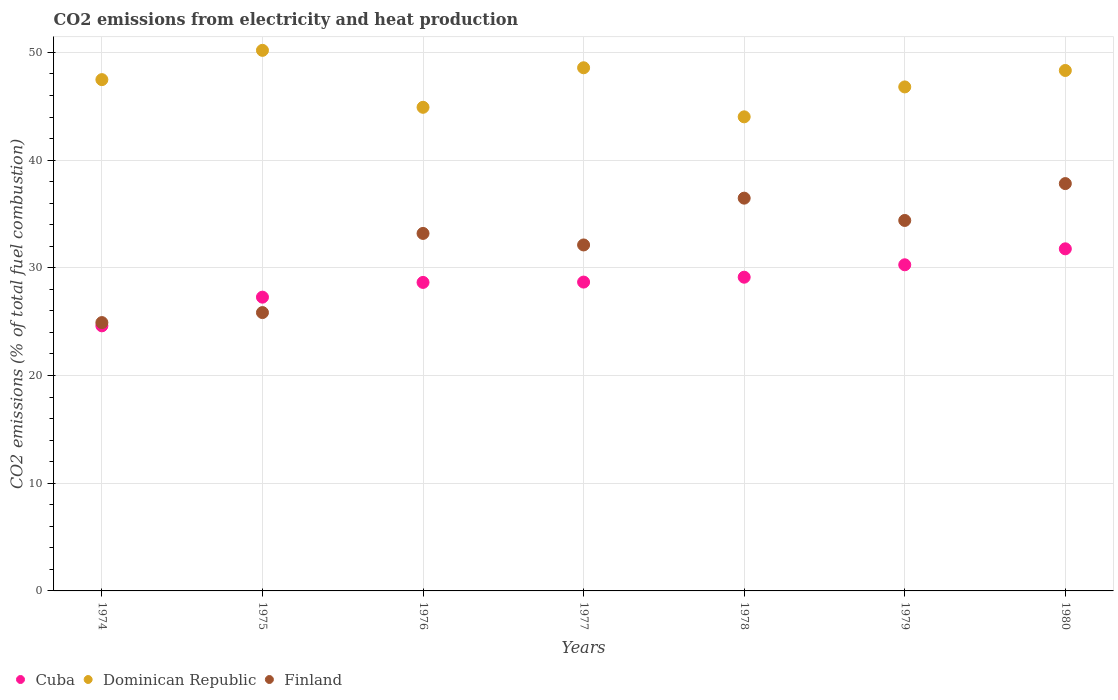How many different coloured dotlines are there?
Make the answer very short. 3. Is the number of dotlines equal to the number of legend labels?
Keep it short and to the point. Yes. What is the amount of CO2 emitted in Cuba in 1978?
Keep it short and to the point. 29.13. Across all years, what is the maximum amount of CO2 emitted in Cuba?
Keep it short and to the point. 31.77. Across all years, what is the minimum amount of CO2 emitted in Finland?
Make the answer very short. 24.92. In which year was the amount of CO2 emitted in Finland maximum?
Your answer should be very brief. 1980. In which year was the amount of CO2 emitted in Cuba minimum?
Offer a terse response. 1974. What is the total amount of CO2 emitted in Finland in the graph?
Offer a very short reply. 224.77. What is the difference between the amount of CO2 emitted in Dominican Republic in 1978 and that in 1980?
Provide a short and direct response. -4.3. What is the difference between the amount of CO2 emitted in Dominican Republic in 1977 and the amount of CO2 emitted in Finland in 1974?
Keep it short and to the point. 23.66. What is the average amount of CO2 emitted in Dominican Republic per year?
Give a very brief answer. 47.18. In the year 1980, what is the difference between the amount of CO2 emitted in Cuba and amount of CO2 emitted in Dominican Republic?
Your answer should be very brief. -16.56. What is the ratio of the amount of CO2 emitted in Finland in 1975 to that in 1977?
Your answer should be very brief. 0.8. Is the amount of CO2 emitted in Finland in 1974 less than that in 1980?
Provide a succinct answer. Yes. What is the difference between the highest and the second highest amount of CO2 emitted in Cuba?
Make the answer very short. 1.48. What is the difference between the highest and the lowest amount of CO2 emitted in Finland?
Your answer should be very brief. 12.91. Is it the case that in every year, the sum of the amount of CO2 emitted in Finland and amount of CO2 emitted in Dominican Republic  is greater than the amount of CO2 emitted in Cuba?
Your answer should be compact. Yes. Is the amount of CO2 emitted in Dominican Republic strictly greater than the amount of CO2 emitted in Finland over the years?
Make the answer very short. Yes. How many years are there in the graph?
Provide a succinct answer. 7. What is the difference between two consecutive major ticks on the Y-axis?
Keep it short and to the point. 10. Are the values on the major ticks of Y-axis written in scientific E-notation?
Your answer should be compact. No. Does the graph contain any zero values?
Make the answer very short. No. Where does the legend appear in the graph?
Your answer should be very brief. Bottom left. How are the legend labels stacked?
Provide a short and direct response. Horizontal. What is the title of the graph?
Your response must be concise. CO2 emissions from electricity and heat production. What is the label or title of the Y-axis?
Your answer should be compact. CO2 emissions (% of total fuel combustion). What is the CO2 emissions (% of total fuel combustion) of Cuba in 1974?
Your response must be concise. 24.61. What is the CO2 emissions (% of total fuel combustion) of Dominican Republic in 1974?
Your answer should be compact. 47.47. What is the CO2 emissions (% of total fuel combustion) of Finland in 1974?
Give a very brief answer. 24.92. What is the CO2 emissions (% of total fuel combustion) in Cuba in 1975?
Provide a succinct answer. 27.28. What is the CO2 emissions (% of total fuel combustion) of Dominican Republic in 1975?
Your answer should be very brief. 50.19. What is the CO2 emissions (% of total fuel combustion) in Finland in 1975?
Ensure brevity in your answer.  25.84. What is the CO2 emissions (% of total fuel combustion) in Cuba in 1976?
Your response must be concise. 28.65. What is the CO2 emissions (% of total fuel combustion) in Dominican Republic in 1976?
Your answer should be very brief. 44.91. What is the CO2 emissions (% of total fuel combustion) in Finland in 1976?
Make the answer very short. 33.19. What is the CO2 emissions (% of total fuel combustion) of Cuba in 1977?
Ensure brevity in your answer.  28.68. What is the CO2 emissions (% of total fuel combustion) in Dominican Republic in 1977?
Give a very brief answer. 48.58. What is the CO2 emissions (% of total fuel combustion) in Finland in 1977?
Provide a succinct answer. 32.12. What is the CO2 emissions (% of total fuel combustion) of Cuba in 1978?
Make the answer very short. 29.13. What is the CO2 emissions (% of total fuel combustion) in Dominican Republic in 1978?
Offer a very short reply. 44.02. What is the CO2 emissions (% of total fuel combustion) in Finland in 1978?
Provide a succinct answer. 36.47. What is the CO2 emissions (% of total fuel combustion) of Cuba in 1979?
Ensure brevity in your answer.  30.28. What is the CO2 emissions (% of total fuel combustion) in Dominican Republic in 1979?
Keep it short and to the point. 46.8. What is the CO2 emissions (% of total fuel combustion) in Finland in 1979?
Provide a short and direct response. 34.4. What is the CO2 emissions (% of total fuel combustion) in Cuba in 1980?
Your response must be concise. 31.77. What is the CO2 emissions (% of total fuel combustion) in Dominican Republic in 1980?
Your answer should be very brief. 48.33. What is the CO2 emissions (% of total fuel combustion) in Finland in 1980?
Ensure brevity in your answer.  37.82. Across all years, what is the maximum CO2 emissions (% of total fuel combustion) in Cuba?
Your answer should be compact. 31.77. Across all years, what is the maximum CO2 emissions (% of total fuel combustion) of Dominican Republic?
Offer a terse response. 50.19. Across all years, what is the maximum CO2 emissions (% of total fuel combustion) in Finland?
Your response must be concise. 37.82. Across all years, what is the minimum CO2 emissions (% of total fuel combustion) of Cuba?
Make the answer very short. 24.61. Across all years, what is the minimum CO2 emissions (% of total fuel combustion) of Dominican Republic?
Make the answer very short. 44.02. Across all years, what is the minimum CO2 emissions (% of total fuel combustion) in Finland?
Give a very brief answer. 24.92. What is the total CO2 emissions (% of total fuel combustion) of Cuba in the graph?
Provide a short and direct response. 200.39. What is the total CO2 emissions (% of total fuel combustion) of Dominican Republic in the graph?
Your answer should be compact. 330.29. What is the total CO2 emissions (% of total fuel combustion) in Finland in the graph?
Ensure brevity in your answer.  224.77. What is the difference between the CO2 emissions (% of total fuel combustion) in Cuba in 1974 and that in 1975?
Your answer should be very brief. -2.66. What is the difference between the CO2 emissions (% of total fuel combustion) in Dominican Republic in 1974 and that in 1975?
Give a very brief answer. -2.72. What is the difference between the CO2 emissions (% of total fuel combustion) in Finland in 1974 and that in 1975?
Make the answer very short. -0.93. What is the difference between the CO2 emissions (% of total fuel combustion) of Cuba in 1974 and that in 1976?
Give a very brief answer. -4.03. What is the difference between the CO2 emissions (% of total fuel combustion) of Dominican Republic in 1974 and that in 1976?
Ensure brevity in your answer.  2.57. What is the difference between the CO2 emissions (% of total fuel combustion) in Finland in 1974 and that in 1976?
Ensure brevity in your answer.  -8.28. What is the difference between the CO2 emissions (% of total fuel combustion) in Cuba in 1974 and that in 1977?
Provide a short and direct response. -4.06. What is the difference between the CO2 emissions (% of total fuel combustion) in Dominican Republic in 1974 and that in 1977?
Your answer should be compact. -1.1. What is the difference between the CO2 emissions (% of total fuel combustion) of Finland in 1974 and that in 1977?
Make the answer very short. -7.21. What is the difference between the CO2 emissions (% of total fuel combustion) in Cuba in 1974 and that in 1978?
Ensure brevity in your answer.  -4.52. What is the difference between the CO2 emissions (% of total fuel combustion) in Dominican Republic in 1974 and that in 1978?
Your response must be concise. 3.45. What is the difference between the CO2 emissions (% of total fuel combustion) in Finland in 1974 and that in 1978?
Provide a short and direct response. -11.55. What is the difference between the CO2 emissions (% of total fuel combustion) in Cuba in 1974 and that in 1979?
Your answer should be compact. -5.67. What is the difference between the CO2 emissions (% of total fuel combustion) in Dominican Republic in 1974 and that in 1979?
Offer a very short reply. 0.68. What is the difference between the CO2 emissions (% of total fuel combustion) in Finland in 1974 and that in 1979?
Your answer should be very brief. -9.48. What is the difference between the CO2 emissions (% of total fuel combustion) of Cuba in 1974 and that in 1980?
Give a very brief answer. -7.15. What is the difference between the CO2 emissions (% of total fuel combustion) in Dominican Republic in 1974 and that in 1980?
Make the answer very short. -0.85. What is the difference between the CO2 emissions (% of total fuel combustion) in Finland in 1974 and that in 1980?
Your answer should be very brief. -12.91. What is the difference between the CO2 emissions (% of total fuel combustion) in Cuba in 1975 and that in 1976?
Your answer should be compact. -1.37. What is the difference between the CO2 emissions (% of total fuel combustion) in Dominican Republic in 1975 and that in 1976?
Your response must be concise. 5.29. What is the difference between the CO2 emissions (% of total fuel combustion) in Finland in 1975 and that in 1976?
Ensure brevity in your answer.  -7.35. What is the difference between the CO2 emissions (% of total fuel combustion) of Cuba in 1975 and that in 1977?
Your answer should be compact. -1.4. What is the difference between the CO2 emissions (% of total fuel combustion) of Dominican Republic in 1975 and that in 1977?
Keep it short and to the point. 1.62. What is the difference between the CO2 emissions (% of total fuel combustion) of Finland in 1975 and that in 1977?
Offer a very short reply. -6.28. What is the difference between the CO2 emissions (% of total fuel combustion) in Cuba in 1975 and that in 1978?
Keep it short and to the point. -1.85. What is the difference between the CO2 emissions (% of total fuel combustion) in Dominican Republic in 1975 and that in 1978?
Provide a succinct answer. 6.17. What is the difference between the CO2 emissions (% of total fuel combustion) of Finland in 1975 and that in 1978?
Give a very brief answer. -10.62. What is the difference between the CO2 emissions (% of total fuel combustion) in Cuba in 1975 and that in 1979?
Make the answer very short. -3.01. What is the difference between the CO2 emissions (% of total fuel combustion) of Dominican Republic in 1975 and that in 1979?
Your response must be concise. 3.4. What is the difference between the CO2 emissions (% of total fuel combustion) of Finland in 1975 and that in 1979?
Keep it short and to the point. -8.55. What is the difference between the CO2 emissions (% of total fuel combustion) of Cuba in 1975 and that in 1980?
Ensure brevity in your answer.  -4.49. What is the difference between the CO2 emissions (% of total fuel combustion) of Dominican Republic in 1975 and that in 1980?
Give a very brief answer. 1.87. What is the difference between the CO2 emissions (% of total fuel combustion) of Finland in 1975 and that in 1980?
Keep it short and to the point. -11.98. What is the difference between the CO2 emissions (% of total fuel combustion) of Cuba in 1976 and that in 1977?
Your response must be concise. -0.03. What is the difference between the CO2 emissions (% of total fuel combustion) of Dominican Republic in 1976 and that in 1977?
Your answer should be compact. -3.67. What is the difference between the CO2 emissions (% of total fuel combustion) in Finland in 1976 and that in 1977?
Your answer should be compact. 1.07. What is the difference between the CO2 emissions (% of total fuel combustion) in Cuba in 1976 and that in 1978?
Make the answer very short. -0.48. What is the difference between the CO2 emissions (% of total fuel combustion) of Dominican Republic in 1976 and that in 1978?
Your answer should be compact. 0.88. What is the difference between the CO2 emissions (% of total fuel combustion) in Finland in 1976 and that in 1978?
Your answer should be compact. -3.28. What is the difference between the CO2 emissions (% of total fuel combustion) of Cuba in 1976 and that in 1979?
Your response must be concise. -1.64. What is the difference between the CO2 emissions (% of total fuel combustion) in Dominican Republic in 1976 and that in 1979?
Ensure brevity in your answer.  -1.89. What is the difference between the CO2 emissions (% of total fuel combustion) in Finland in 1976 and that in 1979?
Your answer should be very brief. -1.2. What is the difference between the CO2 emissions (% of total fuel combustion) of Cuba in 1976 and that in 1980?
Your response must be concise. -3.12. What is the difference between the CO2 emissions (% of total fuel combustion) in Dominican Republic in 1976 and that in 1980?
Make the answer very short. -3.42. What is the difference between the CO2 emissions (% of total fuel combustion) in Finland in 1976 and that in 1980?
Keep it short and to the point. -4.63. What is the difference between the CO2 emissions (% of total fuel combustion) of Cuba in 1977 and that in 1978?
Your answer should be very brief. -0.45. What is the difference between the CO2 emissions (% of total fuel combustion) in Dominican Republic in 1977 and that in 1978?
Keep it short and to the point. 4.56. What is the difference between the CO2 emissions (% of total fuel combustion) in Finland in 1977 and that in 1978?
Ensure brevity in your answer.  -4.35. What is the difference between the CO2 emissions (% of total fuel combustion) of Cuba in 1977 and that in 1979?
Offer a very short reply. -1.61. What is the difference between the CO2 emissions (% of total fuel combustion) in Dominican Republic in 1977 and that in 1979?
Your answer should be very brief. 1.78. What is the difference between the CO2 emissions (% of total fuel combustion) in Finland in 1977 and that in 1979?
Offer a very short reply. -2.27. What is the difference between the CO2 emissions (% of total fuel combustion) of Cuba in 1977 and that in 1980?
Ensure brevity in your answer.  -3.09. What is the difference between the CO2 emissions (% of total fuel combustion) of Dominican Republic in 1977 and that in 1980?
Give a very brief answer. 0.25. What is the difference between the CO2 emissions (% of total fuel combustion) in Finland in 1977 and that in 1980?
Your answer should be compact. -5.7. What is the difference between the CO2 emissions (% of total fuel combustion) of Cuba in 1978 and that in 1979?
Your answer should be very brief. -1.15. What is the difference between the CO2 emissions (% of total fuel combustion) in Dominican Republic in 1978 and that in 1979?
Provide a succinct answer. -2.78. What is the difference between the CO2 emissions (% of total fuel combustion) of Finland in 1978 and that in 1979?
Keep it short and to the point. 2.07. What is the difference between the CO2 emissions (% of total fuel combustion) in Cuba in 1978 and that in 1980?
Your answer should be compact. -2.64. What is the difference between the CO2 emissions (% of total fuel combustion) of Dominican Republic in 1978 and that in 1980?
Make the answer very short. -4.3. What is the difference between the CO2 emissions (% of total fuel combustion) in Finland in 1978 and that in 1980?
Your response must be concise. -1.35. What is the difference between the CO2 emissions (% of total fuel combustion) in Cuba in 1979 and that in 1980?
Provide a short and direct response. -1.48. What is the difference between the CO2 emissions (% of total fuel combustion) in Dominican Republic in 1979 and that in 1980?
Make the answer very short. -1.53. What is the difference between the CO2 emissions (% of total fuel combustion) of Finland in 1979 and that in 1980?
Your answer should be very brief. -3.42. What is the difference between the CO2 emissions (% of total fuel combustion) of Cuba in 1974 and the CO2 emissions (% of total fuel combustion) of Dominican Republic in 1975?
Provide a succinct answer. -25.58. What is the difference between the CO2 emissions (% of total fuel combustion) of Cuba in 1974 and the CO2 emissions (% of total fuel combustion) of Finland in 1975?
Make the answer very short. -1.23. What is the difference between the CO2 emissions (% of total fuel combustion) in Dominican Republic in 1974 and the CO2 emissions (% of total fuel combustion) in Finland in 1975?
Your answer should be very brief. 21.63. What is the difference between the CO2 emissions (% of total fuel combustion) of Cuba in 1974 and the CO2 emissions (% of total fuel combustion) of Dominican Republic in 1976?
Offer a very short reply. -20.29. What is the difference between the CO2 emissions (% of total fuel combustion) in Cuba in 1974 and the CO2 emissions (% of total fuel combustion) in Finland in 1976?
Offer a terse response. -8.58. What is the difference between the CO2 emissions (% of total fuel combustion) in Dominican Republic in 1974 and the CO2 emissions (% of total fuel combustion) in Finland in 1976?
Offer a terse response. 14.28. What is the difference between the CO2 emissions (% of total fuel combustion) in Cuba in 1974 and the CO2 emissions (% of total fuel combustion) in Dominican Republic in 1977?
Provide a succinct answer. -23.96. What is the difference between the CO2 emissions (% of total fuel combustion) in Cuba in 1974 and the CO2 emissions (% of total fuel combustion) in Finland in 1977?
Provide a short and direct response. -7.51. What is the difference between the CO2 emissions (% of total fuel combustion) of Dominican Republic in 1974 and the CO2 emissions (% of total fuel combustion) of Finland in 1977?
Ensure brevity in your answer.  15.35. What is the difference between the CO2 emissions (% of total fuel combustion) in Cuba in 1974 and the CO2 emissions (% of total fuel combustion) in Dominican Republic in 1978?
Offer a very short reply. -19.41. What is the difference between the CO2 emissions (% of total fuel combustion) of Cuba in 1974 and the CO2 emissions (% of total fuel combustion) of Finland in 1978?
Offer a terse response. -11.86. What is the difference between the CO2 emissions (% of total fuel combustion) in Dominican Republic in 1974 and the CO2 emissions (% of total fuel combustion) in Finland in 1978?
Keep it short and to the point. 11. What is the difference between the CO2 emissions (% of total fuel combustion) in Cuba in 1974 and the CO2 emissions (% of total fuel combustion) in Dominican Republic in 1979?
Provide a short and direct response. -22.18. What is the difference between the CO2 emissions (% of total fuel combustion) in Cuba in 1974 and the CO2 emissions (% of total fuel combustion) in Finland in 1979?
Your answer should be compact. -9.79. What is the difference between the CO2 emissions (% of total fuel combustion) in Dominican Republic in 1974 and the CO2 emissions (% of total fuel combustion) in Finland in 1979?
Ensure brevity in your answer.  13.08. What is the difference between the CO2 emissions (% of total fuel combustion) of Cuba in 1974 and the CO2 emissions (% of total fuel combustion) of Dominican Republic in 1980?
Make the answer very short. -23.71. What is the difference between the CO2 emissions (% of total fuel combustion) in Cuba in 1974 and the CO2 emissions (% of total fuel combustion) in Finland in 1980?
Your response must be concise. -13.21. What is the difference between the CO2 emissions (% of total fuel combustion) in Dominican Republic in 1974 and the CO2 emissions (% of total fuel combustion) in Finland in 1980?
Your response must be concise. 9.65. What is the difference between the CO2 emissions (% of total fuel combustion) in Cuba in 1975 and the CO2 emissions (% of total fuel combustion) in Dominican Republic in 1976?
Your response must be concise. -17.63. What is the difference between the CO2 emissions (% of total fuel combustion) in Cuba in 1975 and the CO2 emissions (% of total fuel combustion) in Finland in 1976?
Ensure brevity in your answer.  -5.92. What is the difference between the CO2 emissions (% of total fuel combustion) in Dominican Republic in 1975 and the CO2 emissions (% of total fuel combustion) in Finland in 1976?
Ensure brevity in your answer.  17. What is the difference between the CO2 emissions (% of total fuel combustion) of Cuba in 1975 and the CO2 emissions (% of total fuel combustion) of Dominican Republic in 1977?
Your answer should be very brief. -21.3. What is the difference between the CO2 emissions (% of total fuel combustion) of Cuba in 1975 and the CO2 emissions (% of total fuel combustion) of Finland in 1977?
Provide a succinct answer. -4.85. What is the difference between the CO2 emissions (% of total fuel combustion) of Dominican Republic in 1975 and the CO2 emissions (% of total fuel combustion) of Finland in 1977?
Provide a succinct answer. 18.07. What is the difference between the CO2 emissions (% of total fuel combustion) in Cuba in 1975 and the CO2 emissions (% of total fuel combustion) in Dominican Republic in 1978?
Your answer should be compact. -16.74. What is the difference between the CO2 emissions (% of total fuel combustion) of Cuba in 1975 and the CO2 emissions (% of total fuel combustion) of Finland in 1978?
Ensure brevity in your answer.  -9.19. What is the difference between the CO2 emissions (% of total fuel combustion) in Dominican Republic in 1975 and the CO2 emissions (% of total fuel combustion) in Finland in 1978?
Your response must be concise. 13.72. What is the difference between the CO2 emissions (% of total fuel combustion) in Cuba in 1975 and the CO2 emissions (% of total fuel combustion) in Dominican Republic in 1979?
Make the answer very short. -19.52. What is the difference between the CO2 emissions (% of total fuel combustion) in Cuba in 1975 and the CO2 emissions (% of total fuel combustion) in Finland in 1979?
Ensure brevity in your answer.  -7.12. What is the difference between the CO2 emissions (% of total fuel combustion) of Dominican Republic in 1975 and the CO2 emissions (% of total fuel combustion) of Finland in 1979?
Keep it short and to the point. 15.79. What is the difference between the CO2 emissions (% of total fuel combustion) in Cuba in 1975 and the CO2 emissions (% of total fuel combustion) in Dominican Republic in 1980?
Ensure brevity in your answer.  -21.05. What is the difference between the CO2 emissions (% of total fuel combustion) in Cuba in 1975 and the CO2 emissions (% of total fuel combustion) in Finland in 1980?
Offer a terse response. -10.55. What is the difference between the CO2 emissions (% of total fuel combustion) of Dominican Republic in 1975 and the CO2 emissions (% of total fuel combustion) of Finland in 1980?
Your answer should be compact. 12.37. What is the difference between the CO2 emissions (% of total fuel combustion) of Cuba in 1976 and the CO2 emissions (% of total fuel combustion) of Dominican Republic in 1977?
Offer a terse response. -19.93. What is the difference between the CO2 emissions (% of total fuel combustion) in Cuba in 1976 and the CO2 emissions (% of total fuel combustion) in Finland in 1977?
Your answer should be compact. -3.48. What is the difference between the CO2 emissions (% of total fuel combustion) of Dominican Republic in 1976 and the CO2 emissions (% of total fuel combustion) of Finland in 1977?
Provide a succinct answer. 12.78. What is the difference between the CO2 emissions (% of total fuel combustion) in Cuba in 1976 and the CO2 emissions (% of total fuel combustion) in Dominican Republic in 1978?
Keep it short and to the point. -15.37. What is the difference between the CO2 emissions (% of total fuel combustion) in Cuba in 1976 and the CO2 emissions (% of total fuel combustion) in Finland in 1978?
Give a very brief answer. -7.82. What is the difference between the CO2 emissions (% of total fuel combustion) of Dominican Republic in 1976 and the CO2 emissions (% of total fuel combustion) of Finland in 1978?
Your response must be concise. 8.44. What is the difference between the CO2 emissions (% of total fuel combustion) in Cuba in 1976 and the CO2 emissions (% of total fuel combustion) in Dominican Republic in 1979?
Ensure brevity in your answer.  -18.15. What is the difference between the CO2 emissions (% of total fuel combustion) of Cuba in 1976 and the CO2 emissions (% of total fuel combustion) of Finland in 1979?
Ensure brevity in your answer.  -5.75. What is the difference between the CO2 emissions (% of total fuel combustion) of Dominican Republic in 1976 and the CO2 emissions (% of total fuel combustion) of Finland in 1979?
Your answer should be compact. 10.51. What is the difference between the CO2 emissions (% of total fuel combustion) in Cuba in 1976 and the CO2 emissions (% of total fuel combustion) in Dominican Republic in 1980?
Your answer should be compact. -19.68. What is the difference between the CO2 emissions (% of total fuel combustion) in Cuba in 1976 and the CO2 emissions (% of total fuel combustion) in Finland in 1980?
Give a very brief answer. -9.18. What is the difference between the CO2 emissions (% of total fuel combustion) in Dominican Republic in 1976 and the CO2 emissions (% of total fuel combustion) in Finland in 1980?
Keep it short and to the point. 7.08. What is the difference between the CO2 emissions (% of total fuel combustion) of Cuba in 1977 and the CO2 emissions (% of total fuel combustion) of Dominican Republic in 1978?
Provide a succinct answer. -15.34. What is the difference between the CO2 emissions (% of total fuel combustion) in Cuba in 1977 and the CO2 emissions (% of total fuel combustion) in Finland in 1978?
Offer a very short reply. -7.79. What is the difference between the CO2 emissions (% of total fuel combustion) in Dominican Republic in 1977 and the CO2 emissions (% of total fuel combustion) in Finland in 1978?
Offer a very short reply. 12.11. What is the difference between the CO2 emissions (% of total fuel combustion) of Cuba in 1977 and the CO2 emissions (% of total fuel combustion) of Dominican Republic in 1979?
Your response must be concise. -18.12. What is the difference between the CO2 emissions (% of total fuel combustion) of Cuba in 1977 and the CO2 emissions (% of total fuel combustion) of Finland in 1979?
Offer a terse response. -5.72. What is the difference between the CO2 emissions (% of total fuel combustion) of Dominican Republic in 1977 and the CO2 emissions (% of total fuel combustion) of Finland in 1979?
Provide a succinct answer. 14.18. What is the difference between the CO2 emissions (% of total fuel combustion) of Cuba in 1977 and the CO2 emissions (% of total fuel combustion) of Dominican Republic in 1980?
Provide a succinct answer. -19.65. What is the difference between the CO2 emissions (% of total fuel combustion) in Cuba in 1977 and the CO2 emissions (% of total fuel combustion) in Finland in 1980?
Provide a short and direct response. -9.15. What is the difference between the CO2 emissions (% of total fuel combustion) in Dominican Republic in 1977 and the CO2 emissions (% of total fuel combustion) in Finland in 1980?
Your answer should be compact. 10.75. What is the difference between the CO2 emissions (% of total fuel combustion) of Cuba in 1978 and the CO2 emissions (% of total fuel combustion) of Dominican Republic in 1979?
Provide a succinct answer. -17.67. What is the difference between the CO2 emissions (% of total fuel combustion) of Cuba in 1978 and the CO2 emissions (% of total fuel combustion) of Finland in 1979?
Keep it short and to the point. -5.27. What is the difference between the CO2 emissions (% of total fuel combustion) of Dominican Republic in 1978 and the CO2 emissions (% of total fuel combustion) of Finland in 1979?
Give a very brief answer. 9.62. What is the difference between the CO2 emissions (% of total fuel combustion) in Cuba in 1978 and the CO2 emissions (% of total fuel combustion) in Dominican Republic in 1980?
Offer a terse response. -19.2. What is the difference between the CO2 emissions (% of total fuel combustion) of Cuba in 1978 and the CO2 emissions (% of total fuel combustion) of Finland in 1980?
Offer a very short reply. -8.69. What is the difference between the CO2 emissions (% of total fuel combustion) of Dominican Republic in 1978 and the CO2 emissions (% of total fuel combustion) of Finland in 1980?
Provide a succinct answer. 6.2. What is the difference between the CO2 emissions (% of total fuel combustion) of Cuba in 1979 and the CO2 emissions (% of total fuel combustion) of Dominican Republic in 1980?
Provide a succinct answer. -18.04. What is the difference between the CO2 emissions (% of total fuel combustion) of Cuba in 1979 and the CO2 emissions (% of total fuel combustion) of Finland in 1980?
Your answer should be compact. -7.54. What is the difference between the CO2 emissions (% of total fuel combustion) in Dominican Republic in 1979 and the CO2 emissions (% of total fuel combustion) in Finland in 1980?
Your response must be concise. 8.98. What is the average CO2 emissions (% of total fuel combustion) of Cuba per year?
Provide a short and direct response. 28.63. What is the average CO2 emissions (% of total fuel combustion) in Dominican Republic per year?
Ensure brevity in your answer.  47.19. What is the average CO2 emissions (% of total fuel combustion) in Finland per year?
Offer a terse response. 32.11. In the year 1974, what is the difference between the CO2 emissions (% of total fuel combustion) of Cuba and CO2 emissions (% of total fuel combustion) of Dominican Republic?
Your answer should be compact. -22.86. In the year 1974, what is the difference between the CO2 emissions (% of total fuel combustion) of Cuba and CO2 emissions (% of total fuel combustion) of Finland?
Provide a succinct answer. -0.3. In the year 1974, what is the difference between the CO2 emissions (% of total fuel combustion) of Dominican Republic and CO2 emissions (% of total fuel combustion) of Finland?
Provide a succinct answer. 22.56. In the year 1975, what is the difference between the CO2 emissions (% of total fuel combustion) in Cuba and CO2 emissions (% of total fuel combustion) in Dominican Republic?
Your answer should be very brief. -22.92. In the year 1975, what is the difference between the CO2 emissions (% of total fuel combustion) in Cuba and CO2 emissions (% of total fuel combustion) in Finland?
Ensure brevity in your answer.  1.43. In the year 1975, what is the difference between the CO2 emissions (% of total fuel combustion) of Dominican Republic and CO2 emissions (% of total fuel combustion) of Finland?
Keep it short and to the point. 24.35. In the year 1976, what is the difference between the CO2 emissions (% of total fuel combustion) in Cuba and CO2 emissions (% of total fuel combustion) in Dominican Republic?
Make the answer very short. -16.26. In the year 1976, what is the difference between the CO2 emissions (% of total fuel combustion) in Cuba and CO2 emissions (% of total fuel combustion) in Finland?
Your answer should be very brief. -4.55. In the year 1976, what is the difference between the CO2 emissions (% of total fuel combustion) in Dominican Republic and CO2 emissions (% of total fuel combustion) in Finland?
Provide a succinct answer. 11.71. In the year 1977, what is the difference between the CO2 emissions (% of total fuel combustion) of Cuba and CO2 emissions (% of total fuel combustion) of Dominican Republic?
Offer a terse response. -19.9. In the year 1977, what is the difference between the CO2 emissions (% of total fuel combustion) of Cuba and CO2 emissions (% of total fuel combustion) of Finland?
Make the answer very short. -3.45. In the year 1977, what is the difference between the CO2 emissions (% of total fuel combustion) of Dominican Republic and CO2 emissions (% of total fuel combustion) of Finland?
Your response must be concise. 16.45. In the year 1978, what is the difference between the CO2 emissions (% of total fuel combustion) in Cuba and CO2 emissions (% of total fuel combustion) in Dominican Republic?
Your answer should be very brief. -14.89. In the year 1978, what is the difference between the CO2 emissions (% of total fuel combustion) of Cuba and CO2 emissions (% of total fuel combustion) of Finland?
Offer a terse response. -7.34. In the year 1978, what is the difference between the CO2 emissions (% of total fuel combustion) of Dominican Republic and CO2 emissions (% of total fuel combustion) of Finland?
Your answer should be compact. 7.55. In the year 1979, what is the difference between the CO2 emissions (% of total fuel combustion) of Cuba and CO2 emissions (% of total fuel combustion) of Dominican Republic?
Provide a succinct answer. -16.52. In the year 1979, what is the difference between the CO2 emissions (% of total fuel combustion) of Cuba and CO2 emissions (% of total fuel combustion) of Finland?
Your response must be concise. -4.12. In the year 1979, what is the difference between the CO2 emissions (% of total fuel combustion) in Dominican Republic and CO2 emissions (% of total fuel combustion) in Finland?
Make the answer very short. 12.4. In the year 1980, what is the difference between the CO2 emissions (% of total fuel combustion) in Cuba and CO2 emissions (% of total fuel combustion) in Dominican Republic?
Give a very brief answer. -16.56. In the year 1980, what is the difference between the CO2 emissions (% of total fuel combustion) in Cuba and CO2 emissions (% of total fuel combustion) in Finland?
Your answer should be very brief. -6.06. In the year 1980, what is the difference between the CO2 emissions (% of total fuel combustion) in Dominican Republic and CO2 emissions (% of total fuel combustion) in Finland?
Ensure brevity in your answer.  10.5. What is the ratio of the CO2 emissions (% of total fuel combustion) in Cuba in 1974 to that in 1975?
Offer a very short reply. 0.9. What is the ratio of the CO2 emissions (% of total fuel combustion) in Dominican Republic in 1974 to that in 1975?
Your response must be concise. 0.95. What is the ratio of the CO2 emissions (% of total fuel combustion) of Cuba in 1974 to that in 1976?
Offer a terse response. 0.86. What is the ratio of the CO2 emissions (% of total fuel combustion) in Dominican Republic in 1974 to that in 1976?
Your response must be concise. 1.06. What is the ratio of the CO2 emissions (% of total fuel combustion) of Finland in 1974 to that in 1976?
Give a very brief answer. 0.75. What is the ratio of the CO2 emissions (% of total fuel combustion) in Cuba in 1974 to that in 1977?
Keep it short and to the point. 0.86. What is the ratio of the CO2 emissions (% of total fuel combustion) of Dominican Republic in 1974 to that in 1977?
Give a very brief answer. 0.98. What is the ratio of the CO2 emissions (% of total fuel combustion) in Finland in 1974 to that in 1977?
Provide a short and direct response. 0.78. What is the ratio of the CO2 emissions (% of total fuel combustion) of Cuba in 1974 to that in 1978?
Your answer should be compact. 0.84. What is the ratio of the CO2 emissions (% of total fuel combustion) in Dominican Republic in 1974 to that in 1978?
Your answer should be very brief. 1.08. What is the ratio of the CO2 emissions (% of total fuel combustion) of Finland in 1974 to that in 1978?
Offer a very short reply. 0.68. What is the ratio of the CO2 emissions (% of total fuel combustion) of Cuba in 1974 to that in 1979?
Your answer should be very brief. 0.81. What is the ratio of the CO2 emissions (% of total fuel combustion) in Dominican Republic in 1974 to that in 1979?
Your response must be concise. 1.01. What is the ratio of the CO2 emissions (% of total fuel combustion) of Finland in 1974 to that in 1979?
Give a very brief answer. 0.72. What is the ratio of the CO2 emissions (% of total fuel combustion) in Cuba in 1974 to that in 1980?
Offer a terse response. 0.77. What is the ratio of the CO2 emissions (% of total fuel combustion) in Dominican Republic in 1974 to that in 1980?
Give a very brief answer. 0.98. What is the ratio of the CO2 emissions (% of total fuel combustion) of Finland in 1974 to that in 1980?
Keep it short and to the point. 0.66. What is the ratio of the CO2 emissions (% of total fuel combustion) in Cuba in 1975 to that in 1976?
Keep it short and to the point. 0.95. What is the ratio of the CO2 emissions (% of total fuel combustion) of Dominican Republic in 1975 to that in 1976?
Give a very brief answer. 1.12. What is the ratio of the CO2 emissions (% of total fuel combustion) of Finland in 1975 to that in 1976?
Make the answer very short. 0.78. What is the ratio of the CO2 emissions (% of total fuel combustion) of Cuba in 1975 to that in 1977?
Your answer should be compact. 0.95. What is the ratio of the CO2 emissions (% of total fuel combustion) of Finland in 1975 to that in 1977?
Keep it short and to the point. 0.8. What is the ratio of the CO2 emissions (% of total fuel combustion) in Cuba in 1975 to that in 1978?
Provide a succinct answer. 0.94. What is the ratio of the CO2 emissions (% of total fuel combustion) in Dominican Republic in 1975 to that in 1978?
Your answer should be compact. 1.14. What is the ratio of the CO2 emissions (% of total fuel combustion) in Finland in 1975 to that in 1978?
Give a very brief answer. 0.71. What is the ratio of the CO2 emissions (% of total fuel combustion) in Cuba in 1975 to that in 1979?
Ensure brevity in your answer.  0.9. What is the ratio of the CO2 emissions (% of total fuel combustion) of Dominican Republic in 1975 to that in 1979?
Your answer should be very brief. 1.07. What is the ratio of the CO2 emissions (% of total fuel combustion) of Finland in 1975 to that in 1979?
Your response must be concise. 0.75. What is the ratio of the CO2 emissions (% of total fuel combustion) in Cuba in 1975 to that in 1980?
Provide a short and direct response. 0.86. What is the ratio of the CO2 emissions (% of total fuel combustion) in Dominican Republic in 1975 to that in 1980?
Your response must be concise. 1.04. What is the ratio of the CO2 emissions (% of total fuel combustion) in Finland in 1975 to that in 1980?
Keep it short and to the point. 0.68. What is the ratio of the CO2 emissions (% of total fuel combustion) in Cuba in 1976 to that in 1977?
Keep it short and to the point. 1. What is the ratio of the CO2 emissions (% of total fuel combustion) in Dominican Republic in 1976 to that in 1977?
Provide a short and direct response. 0.92. What is the ratio of the CO2 emissions (% of total fuel combustion) in Cuba in 1976 to that in 1978?
Your response must be concise. 0.98. What is the ratio of the CO2 emissions (% of total fuel combustion) in Dominican Republic in 1976 to that in 1978?
Provide a short and direct response. 1.02. What is the ratio of the CO2 emissions (% of total fuel combustion) of Finland in 1976 to that in 1978?
Make the answer very short. 0.91. What is the ratio of the CO2 emissions (% of total fuel combustion) in Cuba in 1976 to that in 1979?
Your answer should be compact. 0.95. What is the ratio of the CO2 emissions (% of total fuel combustion) in Dominican Republic in 1976 to that in 1979?
Provide a short and direct response. 0.96. What is the ratio of the CO2 emissions (% of total fuel combustion) of Cuba in 1976 to that in 1980?
Your response must be concise. 0.9. What is the ratio of the CO2 emissions (% of total fuel combustion) of Dominican Republic in 1976 to that in 1980?
Your answer should be compact. 0.93. What is the ratio of the CO2 emissions (% of total fuel combustion) in Finland in 1976 to that in 1980?
Your response must be concise. 0.88. What is the ratio of the CO2 emissions (% of total fuel combustion) of Cuba in 1977 to that in 1978?
Ensure brevity in your answer.  0.98. What is the ratio of the CO2 emissions (% of total fuel combustion) of Dominican Republic in 1977 to that in 1978?
Keep it short and to the point. 1.1. What is the ratio of the CO2 emissions (% of total fuel combustion) of Finland in 1977 to that in 1978?
Your answer should be very brief. 0.88. What is the ratio of the CO2 emissions (% of total fuel combustion) in Cuba in 1977 to that in 1979?
Offer a terse response. 0.95. What is the ratio of the CO2 emissions (% of total fuel combustion) in Dominican Republic in 1977 to that in 1979?
Provide a succinct answer. 1.04. What is the ratio of the CO2 emissions (% of total fuel combustion) in Finland in 1977 to that in 1979?
Offer a terse response. 0.93. What is the ratio of the CO2 emissions (% of total fuel combustion) of Cuba in 1977 to that in 1980?
Ensure brevity in your answer.  0.9. What is the ratio of the CO2 emissions (% of total fuel combustion) of Dominican Republic in 1977 to that in 1980?
Ensure brevity in your answer.  1.01. What is the ratio of the CO2 emissions (% of total fuel combustion) of Finland in 1977 to that in 1980?
Provide a succinct answer. 0.85. What is the ratio of the CO2 emissions (% of total fuel combustion) in Cuba in 1978 to that in 1979?
Your answer should be very brief. 0.96. What is the ratio of the CO2 emissions (% of total fuel combustion) of Dominican Republic in 1978 to that in 1979?
Your answer should be very brief. 0.94. What is the ratio of the CO2 emissions (% of total fuel combustion) in Finland in 1978 to that in 1979?
Your answer should be very brief. 1.06. What is the ratio of the CO2 emissions (% of total fuel combustion) in Cuba in 1978 to that in 1980?
Your answer should be compact. 0.92. What is the ratio of the CO2 emissions (% of total fuel combustion) of Dominican Republic in 1978 to that in 1980?
Provide a short and direct response. 0.91. What is the ratio of the CO2 emissions (% of total fuel combustion) in Finland in 1978 to that in 1980?
Your response must be concise. 0.96. What is the ratio of the CO2 emissions (% of total fuel combustion) of Cuba in 1979 to that in 1980?
Keep it short and to the point. 0.95. What is the ratio of the CO2 emissions (% of total fuel combustion) in Dominican Republic in 1979 to that in 1980?
Ensure brevity in your answer.  0.97. What is the ratio of the CO2 emissions (% of total fuel combustion) in Finland in 1979 to that in 1980?
Ensure brevity in your answer.  0.91. What is the difference between the highest and the second highest CO2 emissions (% of total fuel combustion) in Cuba?
Offer a terse response. 1.48. What is the difference between the highest and the second highest CO2 emissions (% of total fuel combustion) in Dominican Republic?
Offer a terse response. 1.62. What is the difference between the highest and the second highest CO2 emissions (% of total fuel combustion) of Finland?
Keep it short and to the point. 1.35. What is the difference between the highest and the lowest CO2 emissions (% of total fuel combustion) of Cuba?
Your response must be concise. 7.15. What is the difference between the highest and the lowest CO2 emissions (% of total fuel combustion) of Dominican Republic?
Provide a succinct answer. 6.17. What is the difference between the highest and the lowest CO2 emissions (% of total fuel combustion) in Finland?
Offer a terse response. 12.91. 